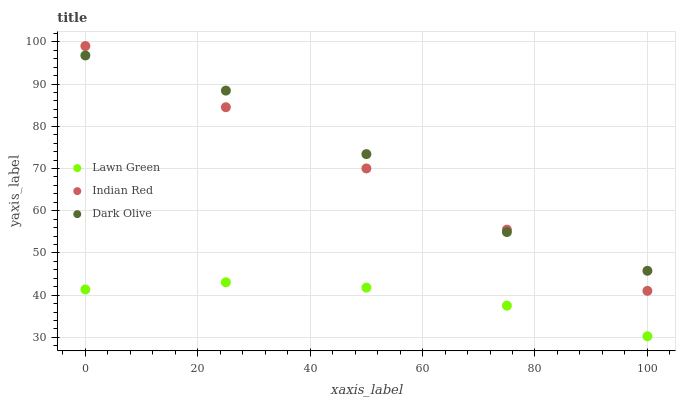Does Lawn Green have the minimum area under the curve?
Answer yes or no. Yes. Does Dark Olive have the maximum area under the curve?
Answer yes or no. Yes. Does Indian Red have the minimum area under the curve?
Answer yes or no. No. Does Indian Red have the maximum area under the curve?
Answer yes or no. No. Is Indian Red the smoothest?
Answer yes or no. Yes. Is Dark Olive the roughest?
Answer yes or no. Yes. Is Dark Olive the smoothest?
Answer yes or no. No. Is Indian Red the roughest?
Answer yes or no. No. Does Lawn Green have the lowest value?
Answer yes or no. Yes. Does Indian Red have the lowest value?
Answer yes or no. No. Does Indian Red have the highest value?
Answer yes or no. Yes. Does Dark Olive have the highest value?
Answer yes or no. No. Is Lawn Green less than Dark Olive?
Answer yes or no. Yes. Is Indian Red greater than Lawn Green?
Answer yes or no. Yes. Does Dark Olive intersect Indian Red?
Answer yes or no. Yes. Is Dark Olive less than Indian Red?
Answer yes or no. No. Is Dark Olive greater than Indian Red?
Answer yes or no. No. Does Lawn Green intersect Dark Olive?
Answer yes or no. No. 